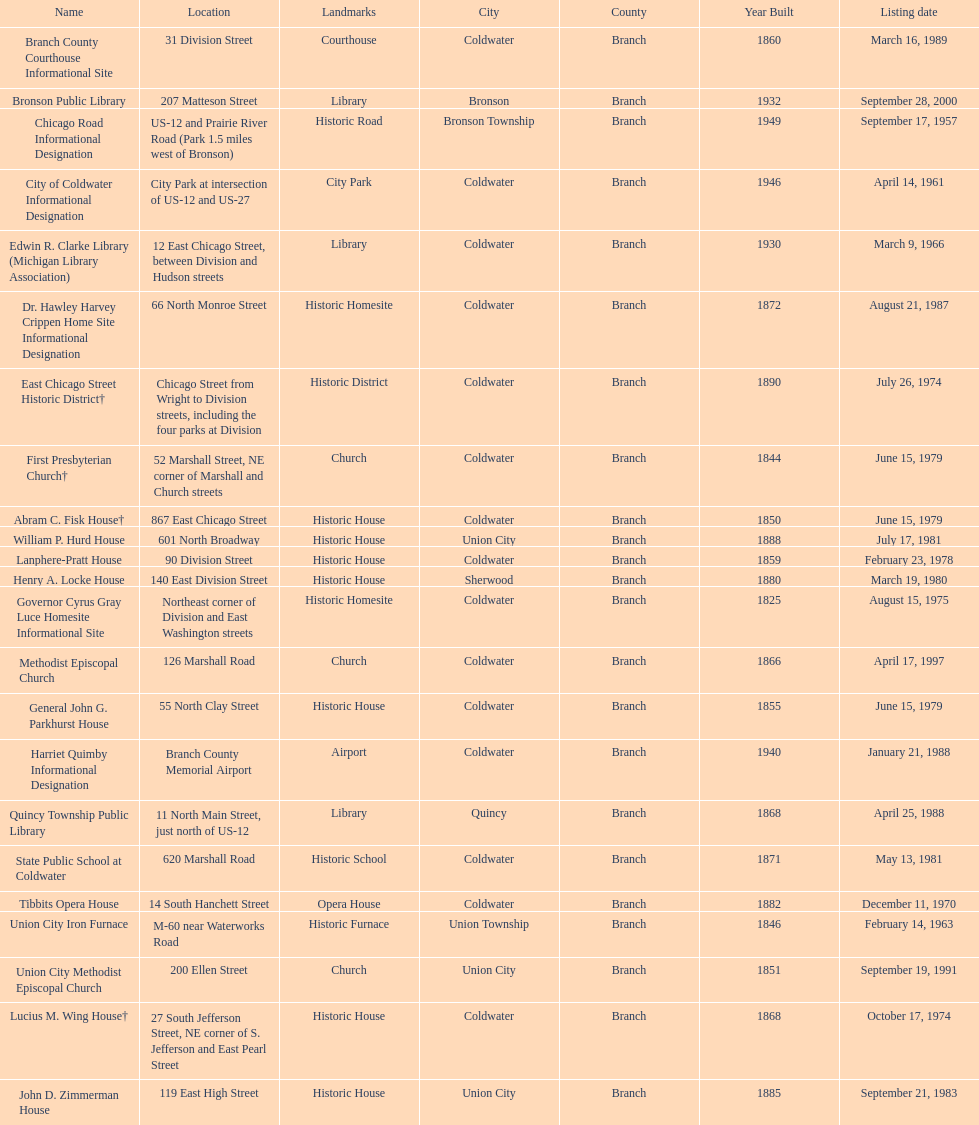What is the name with the only listing date on april 14, 1961 City of Coldwater. Could you parse the entire table as a dict? {'header': ['Name', 'Location', 'Landmarks', 'City', 'County', 'Year Built', 'Listing date'], 'rows': [['Branch County Courthouse Informational Site', '31 Division Street', 'Courthouse', 'Coldwater', 'Branch', '1860', 'March 16, 1989'], ['Bronson Public Library', '207 Matteson Street', 'Library', 'Bronson', 'Branch', '1932', 'September 28, 2000'], ['Chicago Road Informational Designation', 'US-12 and Prairie River Road (Park 1.5 miles west of Bronson)', 'Historic Road', 'Bronson Township', 'Branch', '1949', 'September 17, 1957'], ['City of Coldwater Informational Designation', 'City Park at intersection of US-12 and US-27', 'City Park', 'Coldwater', 'Branch', '1946', 'April 14, 1961'], ['Edwin R. Clarke Library (Michigan Library Association)', '12 East Chicago Street, between Division and Hudson streets', 'Library', 'Coldwater', 'Branch', '1930', 'March 9, 1966'], ['Dr. Hawley Harvey Crippen Home Site Informational Designation', '66 North Monroe Street', 'Historic Homesite', 'Coldwater', 'Branch', '1872', 'August 21, 1987'], ['East Chicago Street Historic District†', 'Chicago Street from Wright to Division streets, including the four parks at Division', 'Historic District', 'Coldwater', 'Branch', '1890', 'July 26, 1974'], ['First Presbyterian Church†', '52 Marshall Street, NE corner of Marshall and Church streets', 'Church', 'Coldwater', 'Branch', '1844', 'June 15, 1979'], ['Abram C. Fisk House†', '867 East Chicago Street', 'Historic House', 'Coldwater', 'Branch', '1850', 'June 15, 1979'], ['William P. Hurd House', '601 North Broadway', 'Historic House', 'Union City', 'Branch', '1888', 'July 17, 1981'], ['Lanphere-Pratt House', '90 Division Street', 'Historic House', 'Coldwater', 'Branch', '1859', 'February 23, 1978'], ['Henry A. Locke House', '140 East Division Street', 'Historic House', 'Sherwood', 'Branch', '1880', 'March 19, 1980'], ['Governor Cyrus Gray Luce Homesite Informational Site', 'Northeast corner of Division and East Washington streets', 'Historic Homesite', 'Coldwater', 'Branch', '1825', 'August 15, 1975'], ['Methodist Episcopal Church', '126 Marshall Road', 'Church', 'Coldwater', 'Branch', '1866', 'April 17, 1997'], ['General John G. Parkhurst House', '55 North Clay Street', 'Historic House', 'Coldwater', 'Branch', '1855', 'June 15, 1979'], ['Harriet Quimby Informational Designation', 'Branch County Memorial Airport', 'Airport', 'Coldwater', 'Branch', '1940', 'January 21, 1988'], ['Quincy Township Public Library', '11 North Main Street, just north of US-12', 'Library', 'Quincy', 'Branch', '1868', 'April 25, 1988'], ['State Public School at Coldwater', '620 Marshall Road', 'Historic School', 'Coldwater', 'Branch', '1871', 'May 13, 1981'], ['Tibbits Opera House', '14 South Hanchett Street', 'Opera House', 'Coldwater', 'Branch', '1882', 'December 11, 1970'], ['Union City Iron Furnace', 'M-60 near Waterworks Road', 'Historic Furnace', 'Union Township', 'Branch', '1846', 'February 14, 1963'], ['Union City Methodist Episcopal Church', '200 Ellen Street', 'Church', 'Union City', 'Branch', '1851', 'September 19, 1991'], ['Lucius M. Wing House†', '27 South Jefferson Street, NE corner of S. Jefferson and East Pearl Street', 'Historic House', 'Coldwater', 'Branch', '1868', 'October 17, 1974'], ['John D. Zimmerman House', '119 East High Street', 'Historic House', 'Union City', 'Branch', '1885', 'September 21, 1983']]} 